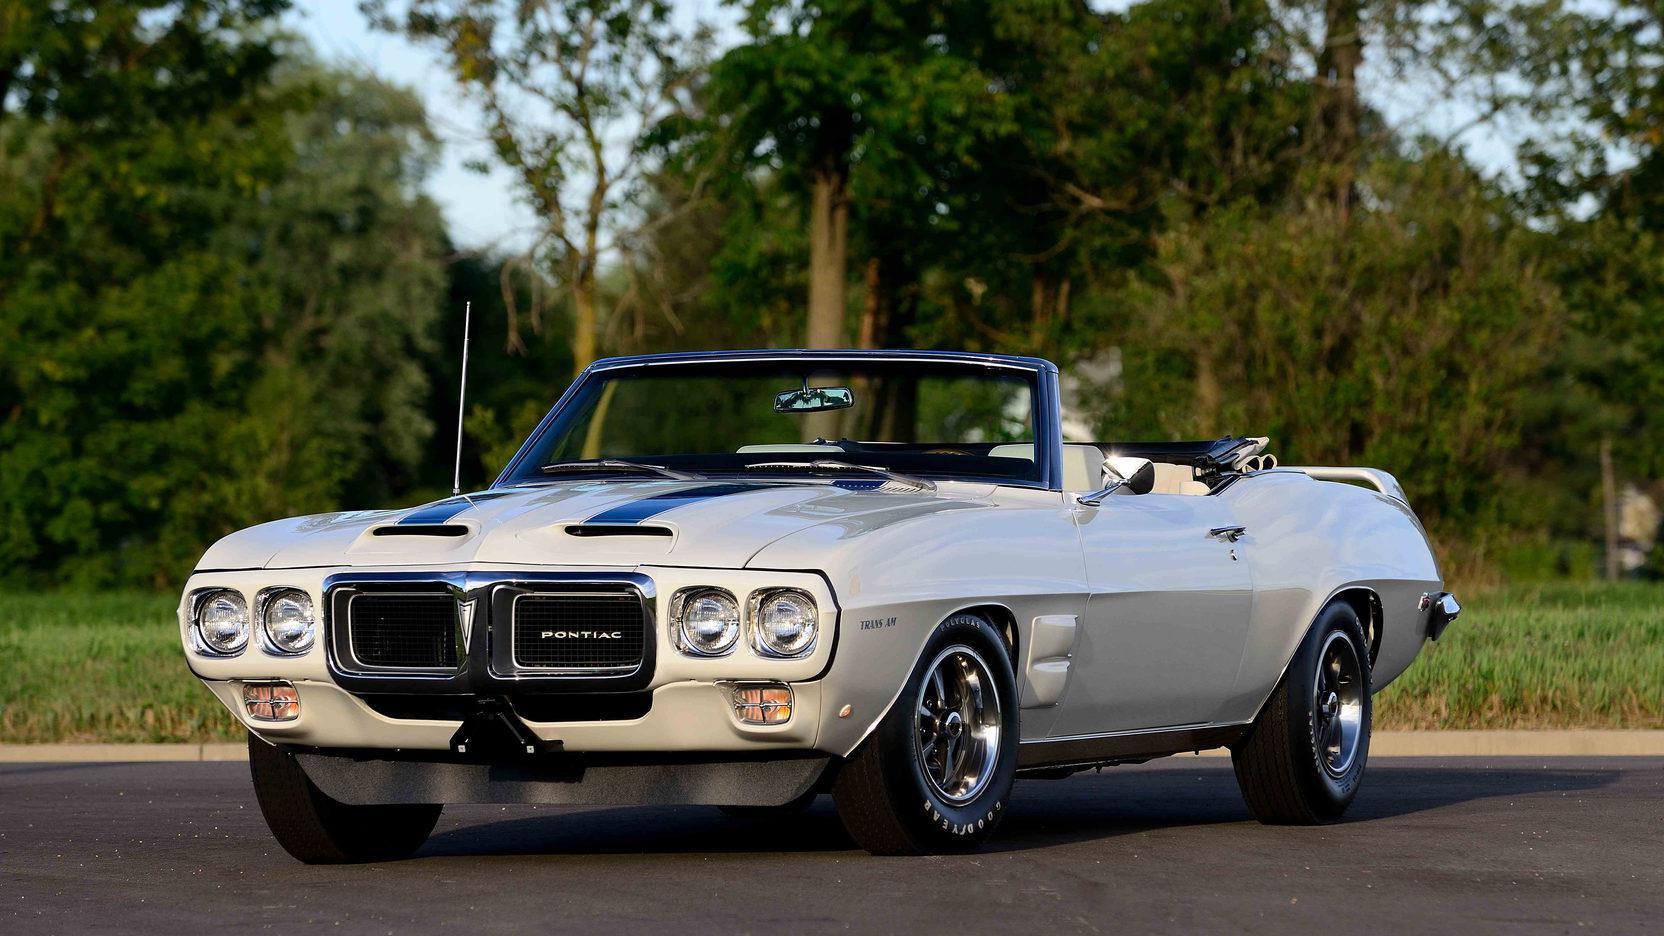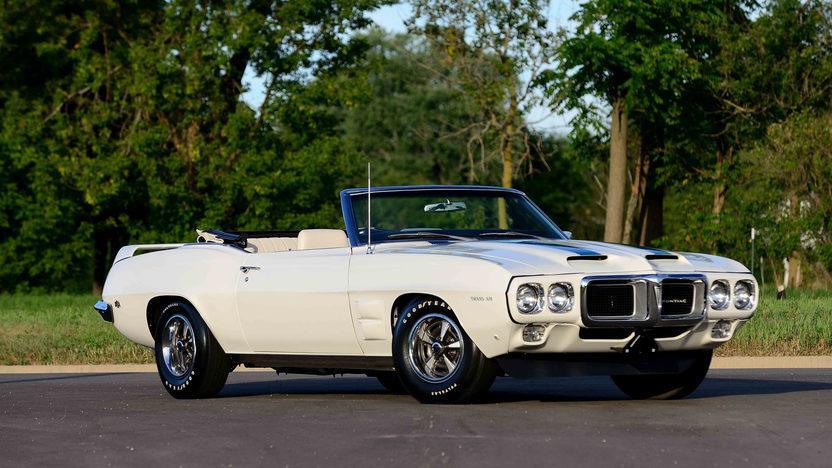The first image is the image on the left, the second image is the image on the right. Analyze the images presented: Is the assertion "Two cars are facing left." valid? Answer yes or no. No. 